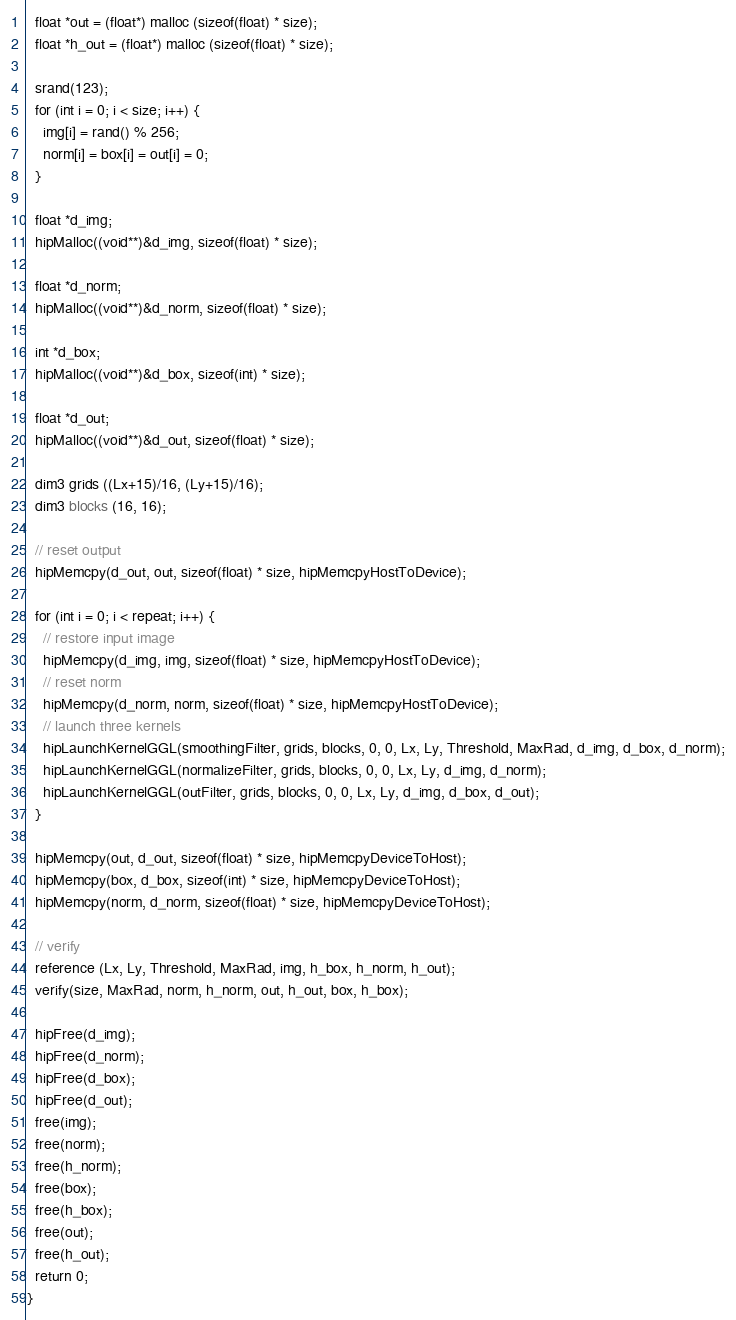<code> <loc_0><loc_0><loc_500><loc_500><_Cuda_>  float *out = (float*) malloc (sizeof(float) * size);
  float *h_out = (float*) malloc (sizeof(float) * size);

  srand(123);
  for (int i = 0; i < size; i++) {
    img[i] = rand() % 256;
    norm[i] = box[i] = out[i] = 0;
  }

  float *d_img;
  hipMalloc((void**)&d_img, sizeof(float) * size);

  float *d_norm;
  hipMalloc((void**)&d_norm, sizeof(float) * size);

  int *d_box;
  hipMalloc((void**)&d_box, sizeof(int) * size);

  float *d_out;
  hipMalloc((void**)&d_out, sizeof(float) * size);

  dim3 grids ((Lx+15)/16, (Ly+15)/16);
  dim3 blocks (16, 16);

  // reset output
  hipMemcpy(d_out, out, sizeof(float) * size, hipMemcpyHostToDevice);

  for (int i = 0; i < repeat; i++) {
    // restore input image
    hipMemcpy(d_img, img, sizeof(float) * size, hipMemcpyHostToDevice);
    // reset norm
    hipMemcpy(d_norm, norm, sizeof(float) * size, hipMemcpyHostToDevice);
    // launch three kernels
    hipLaunchKernelGGL(smoothingFilter, grids, blocks, 0, 0, Lx, Ly, Threshold, MaxRad, d_img, d_box, d_norm);
    hipLaunchKernelGGL(normalizeFilter, grids, blocks, 0, 0, Lx, Ly, d_img, d_norm);
    hipLaunchKernelGGL(outFilter, grids, blocks, 0, 0, Lx, Ly, d_img, d_box, d_out);
  }

  hipMemcpy(out, d_out, sizeof(float) * size, hipMemcpyDeviceToHost);
  hipMemcpy(box, d_box, sizeof(int) * size, hipMemcpyDeviceToHost);
  hipMemcpy(norm, d_norm, sizeof(float) * size, hipMemcpyDeviceToHost);

  // verify
  reference (Lx, Ly, Threshold, MaxRad, img, h_box, h_norm, h_out);
  verify(size, MaxRad, norm, h_norm, out, h_out, box, h_box);

  hipFree(d_img);
  hipFree(d_norm);
  hipFree(d_box);
  hipFree(d_out);
  free(img);
  free(norm);
  free(h_norm);
  free(box);
  free(h_box);
  free(out);
  free(h_out);
  return 0;
}
</code> 